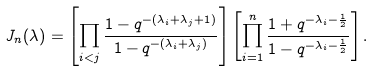<formula> <loc_0><loc_0><loc_500><loc_500>J _ { n } ( \lambda ) = \left [ \prod _ { i < j } \frac { 1 - q ^ { - ( \lambda _ { i } + \lambda _ { j } + 1 ) } } { 1 - q ^ { - ( \lambda _ { i } + \lambda _ { j } ) } } \right ] \left [ \prod _ { i = 1 } ^ { n } \frac { 1 + q ^ { - \lambda _ { i } - \frac { 1 } { 2 } } } { 1 - q ^ { - \lambda _ { i } - \frac { 1 } { 2 } } } \right ] .</formula> 